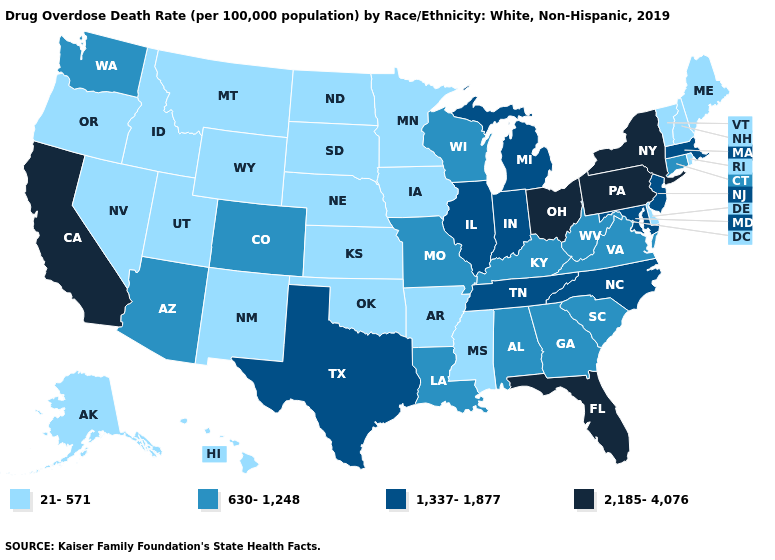Among the states that border Georgia , which have the highest value?
Concise answer only. Florida. Does the map have missing data?
Keep it brief. No. Which states have the highest value in the USA?
Concise answer only. California, Florida, New York, Ohio, Pennsylvania. Name the states that have a value in the range 1,337-1,877?
Write a very short answer. Illinois, Indiana, Maryland, Massachusetts, Michigan, New Jersey, North Carolina, Tennessee, Texas. Which states have the highest value in the USA?
Short answer required. California, Florida, New York, Ohio, Pennsylvania. Does the first symbol in the legend represent the smallest category?
Answer briefly. Yes. Does New Jersey have the lowest value in the USA?
Short answer required. No. Does Idaho have the lowest value in the USA?
Give a very brief answer. Yes. What is the value of Indiana?
Short answer required. 1,337-1,877. Name the states that have a value in the range 2,185-4,076?
Concise answer only. California, Florida, New York, Ohio, Pennsylvania. What is the highest value in the West ?
Be succinct. 2,185-4,076. Does South Dakota have the highest value in the USA?
Concise answer only. No. What is the lowest value in states that border Nebraska?
Give a very brief answer. 21-571. What is the value of Oregon?
Quick response, please. 21-571. Is the legend a continuous bar?
Keep it brief. No. 